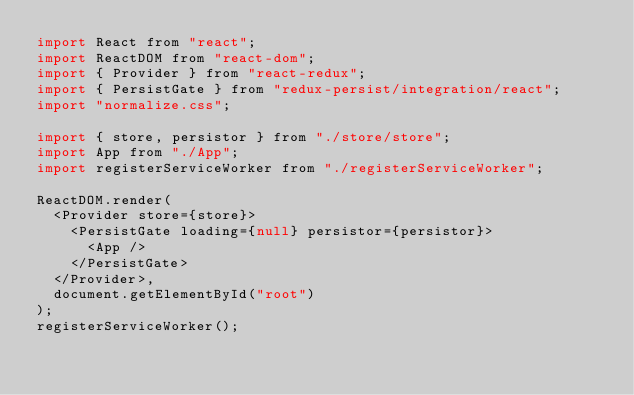Convert code to text. <code><loc_0><loc_0><loc_500><loc_500><_JavaScript_>import React from "react";
import ReactDOM from "react-dom";
import { Provider } from "react-redux";
import { PersistGate } from "redux-persist/integration/react";
import "normalize.css";

import { store, persistor } from "./store/store";
import App from "./App";
import registerServiceWorker from "./registerServiceWorker";

ReactDOM.render(
  <Provider store={store}>
    <PersistGate loading={null} persistor={persistor}>
      <App />
    </PersistGate>
  </Provider>,
  document.getElementById("root")
);
registerServiceWorker();
</code> 